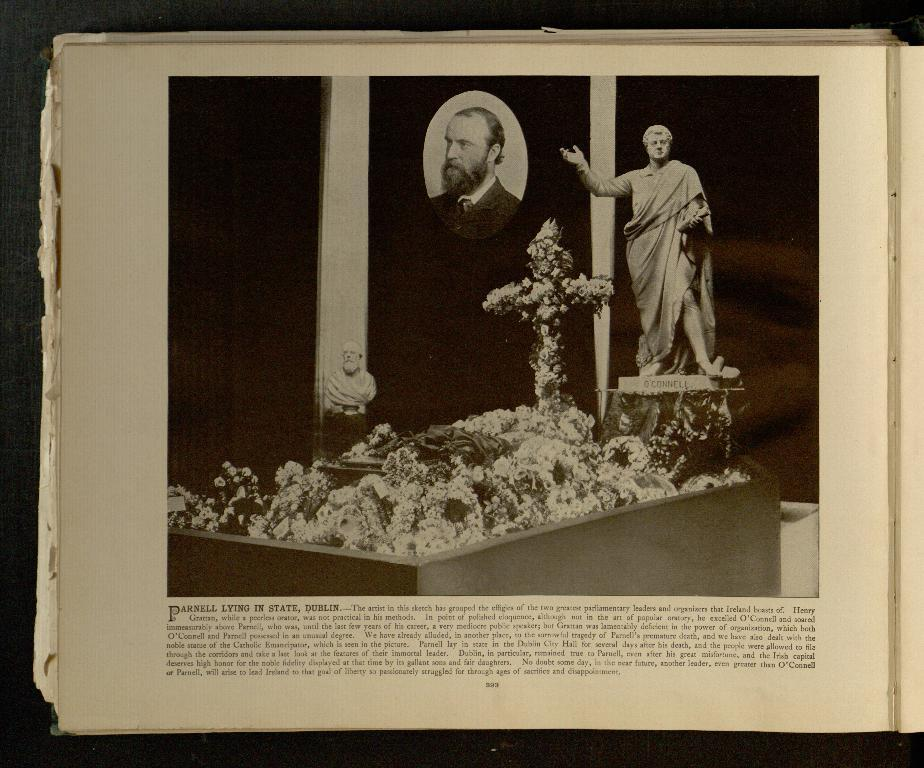What is the main object in the image? There is a book in the image. What type of content can be found in the book? The book contains text and pictures. What is the shocking title of the book in the image? There is no title mentioned in the provided facts, and the image does not show any text that would indicate a title. 